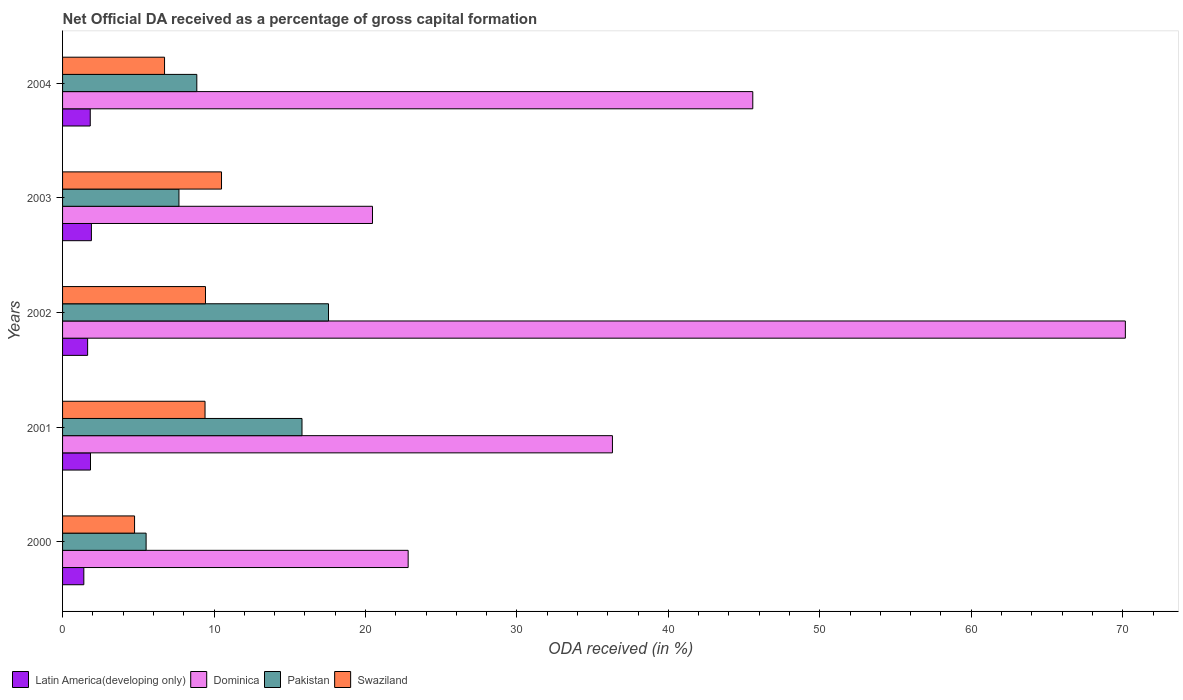How many groups of bars are there?
Make the answer very short. 5. Are the number of bars on each tick of the Y-axis equal?
Your answer should be very brief. Yes. How many bars are there on the 3rd tick from the bottom?
Keep it short and to the point. 4. What is the label of the 4th group of bars from the top?
Offer a terse response. 2001. What is the net ODA received in Dominica in 2002?
Your answer should be very brief. 70.17. Across all years, what is the maximum net ODA received in Pakistan?
Ensure brevity in your answer.  17.56. Across all years, what is the minimum net ODA received in Pakistan?
Provide a succinct answer. 5.52. In which year was the net ODA received in Latin America(developing only) minimum?
Your answer should be compact. 2000. What is the total net ODA received in Latin America(developing only) in the graph?
Offer a very short reply. 8.64. What is the difference between the net ODA received in Swaziland in 2002 and that in 2004?
Provide a short and direct response. 2.7. What is the difference between the net ODA received in Swaziland in 2001 and the net ODA received in Pakistan in 2003?
Ensure brevity in your answer.  1.72. What is the average net ODA received in Dominica per year?
Provide a short and direct response. 39.07. In the year 2002, what is the difference between the net ODA received in Latin America(developing only) and net ODA received in Swaziland?
Ensure brevity in your answer.  -7.78. In how many years, is the net ODA received in Latin America(developing only) greater than 18 %?
Give a very brief answer. 0. What is the ratio of the net ODA received in Swaziland in 2001 to that in 2002?
Provide a short and direct response. 1. Is the net ODA received in Pakistan in 2001 less than that in 2003?
Your answer should be very brief. No. What is the difference between the highest and the second highest net ODA received in Latin America(developing only)?
Make the answer very short. 0.06. What is the difference between the highest and the lowest net ODA received in Swaziland?
Keep it short and to the point. 5.74. Is it the case that in every year, the sum of the net ODA received in Pakistan and net ODA received in Swaziland is greater than the sum of net ODA received in Dominica and net ODA received in Latin America(developing only)?
Give a very brief answer. No. What does the 4th bar from the top in 2004 represents?
Your answer should be compact. Latin America(developing only). What does the 1st bar from the bottom in 2004 represents?
Make the answer very short. Latin America(developing only). Is it the case that in every year, the sum of the net ODA received in Pakistan and net ODA received in Swaziland is greater than the net ODA received in Latin America(developing only)?
Make the answer very short. Yes. How many bars are there?
Keep it short and to the point. 20. Are all the bars in the graph horizontal?
Your answer should be compact. Yes. How many years are there in the graph?
Offer a terse response. 5. What is the difference between two consecutive major ticks on the X-axis?
Keep it short and to the point. 10. Are the values on the major ticks of X-axis written in scientific E-notation?
Your response must be concise. No. Does the graph contain any zero values?
Your answer should be very brief. No. Does the graph contain grids?
Ensure brevity in your answer.  No. Where does the legend appear in the graph?
Your answer should be very brief. Bottom left. How many legend labels are there?
Keep it short and to the point. 4. What is the title of the graph?
Offer a terse response. Net Official DA received as a percentage of gross capital formation. Does "Other small states" appear as one of the legend labels in the graph?
Keep it short and to the point. No. What is the label or title of the X-axis?
Your answer should be compact. ODA received (in %). What is the ODA received (in %) in Latin America(developing only) in 2000?
Your answer should be compact. 1.4. What is the ODA received (in %) in Dominica in 2000?
Your response must be concise. 22.82. What is the ODA received (in %) in Pakistan in 2000?
Ensure brevity in your answer.  5.52. What is the ODA received (in %) of Swaziland in 2000?
Your answer should be compact. 4.75. What is the ODA received (in %) in Latin America(developing only) in 2001?
Your answer should be compact. 1.84. What is the ODA received (in %) of Dominica in 2001?
Offer a very short reply. 36.31. What is the ODA received (in %) of Pakistan in 2001?
Ensure brevity in your answer.  15.81. What is the ODA received (in %) in Swaziland in 2001?
Provide a short and direct response. 9.41. What is the ODA received (in %) of Latin America(developing only) in 2002?
Give a very brief answer. 1.65. What is the ODA received (in %) of Dominica in 2002?
Make the answer very short. 70.17. What is the ODA received (in %) of Pakistan in 2002?
Make the answer very short. 17.56. What is the ODA received (in %) in Swaziland in 2002?
Ensure brevity in your answer.  9.44. What is the ODA received (in %) of Latin America(developing only) in 2003?
Your response must be concise. 1.9. What is the ODA received (in %) of Dominica in 2003?
Provide a succinct answer. 20.46. What is the ODA received (in %) in Pakistan in 2003?
Give a very brief answer. 7.68. What is the ODA received (in %) of Swaziland in 2003?
Your answer should be compact. 10.5. What is the ODA received (in %) of Latin America(developing only) in 2004?
Your answer should be very brief. 1.83. What is the ODA received (in %) of Dominica in 2004?
Offer a terse response. 45.57. What is the ODA received (in %) of Pakistan in 2004?
Give a very brief answer. 8.86. What is the ODA received (in %) of Swaziland in 2004?
Your answer should be compact. 6.73. Across all years, what is the maximum ODA received (in %) of Latin America(developing only)?
Your response must be concise. 1.9. Across all years, what is the maximum ODA received (in %) of Dominica?
Give a very brief answer. 70.17. Across all years, what is the maximum ODA received (in %) of Pakistan?
Your answer should be compact. 17.56. Across all years, what is the maximum ODA received (in %) of Swaziland?
Ensure brevity in your answer.  10.5. Across all years, what is the minimum ODA received (in %) in Latin America(developing only)?
Make the answer very short. 1.4. Across all years, what is the minimum ODA received (in %) of Dominica?
Provide a short and direct response. 20.46. Across all years, what is the minimum ODA received (in %) in Pakistan?
Your response must be concise. 5.52. Across all years, what is the minimum ODA received (in %) in Swaziland?
Your response must be concise. 4.75. What is the total ODA received (in %) in Latin America(developing only) in the graph?
Give a very brief answer. 8.64. What is the total ODA received (in %) of Dominica in the graph?
Your response must be concise. 195.33. What is the total ODA received (in %) in Pakistan in the graph?
Your response must be concise. 55.43. What is the total ODA received (in %) of Swaziland in the graph?
Keep it short and to the point. 40.83. What is the difference between the ODA received (in %) in Latin America(developing only) in 2000 and that in 2001?
Offer a very short reply. -0.44. What is the difference between the ODA received (in %) in Dominica in 2000 and that in 2001?
Ensure brevity in your answer.  -13.49. What is the difference between the ODA received (in %) of Pakistan in 2000 and that in 2001?
Make the answer very short. -10.29. What is the difference between the ODA received (in %) of Swaziland in 2000 and that in 2001?
Keep it short and to the point. -4.65. What is the difference between the ODA received (in %) of Latin America(developing only) in 2000 and that in 2002?
Keep it short and to the point. -0.25. What is the difference between the ODA received (in %) in Dominica in 2000 and that in 2002?
Provide a short and direct response. -47.35. What is the difference between the ODA received (in %) of Pakistan in 2000 and that in 2002?
Make the answer very short. -12.04. What is the difference between the ODA received (in %) in Swaziland in 2000 and that in 2002?
Keep it short and to the point. -4.68. What is the difference between the ODA received (in %) in Latin America(developing only) in 2000 and that in 2003?
Ensure brevity in your answer.  -0.5. What is the difference between the ODA received (in %) of Dominica in 2000 and that in 2003?
Give a very brief answer. 2.35. What is the difference between the ODA received (in %) in Pakistan in 2000 and that in 2003?
Give a very brief answer. -2.17. What is the difference between the ODA received (in %) in Swaziland in 2000 and that in 2003?
Your response must be concise. -5.74. What is the difference between the ODA received (in %) in Latin America(developing only) in 2000 and that in 2004?
Provide a succinct answer. -0.42. What is the difference between the ODA received (in %) in Dominica in 2000 and that in 2004?
Offer a very short reply. -22.75. What is the difference between the ODA received (in %) in Pakistan in 2000 and that in 2004?
Your answer should be very brief. -3.35. What is the difference between the ODA received (in %) of Swaziland in 2000 and that in 2004?
Offer a terse response. -1.98. What is the difference between the ODA received (in %) of Latin America(developing only) in 2001 and that in 2002?
Keep it short and to the point. 0.19. What is the difference between the ODA received (in %) in Dominica in 2001 and that in 2002?
Make the answer very short. -33.87. What is the difference between the ODA received (in %) of Pakistan in 2001 and that in 2002?
Keep it short and to the point. -1.75. What is the difference between the ODA received (in %) of Swaziland in 2001 and that in 2002?
Ensure brevity in your answer.  -0.03. What is the difference between the ODA received (in %) of Latin America(developing only) in 2001 and that in 2003?
Your answer should be compact. -0.06. What is the difference between the ODA received (in %) of Dominica in 2001 and that in 2003?
Make the answer very short. 15.84. What is the difference between the ODA received (in %) in Pakistan in 2001 and that in 2003?
Your answer should be compact. 8.12. What is the difference between the ODA received (in %) of Swaziland in 2001 and that in 2003?
Your answer should be compact. -1.09. What is the difference between the ODA received (in %) of Latin America(developing only) in 2001 and that in 2004?
Offer a terse response. 0.02. What is the difference between the ODA received (in %) of Dominica in 2001 and that in 2004?
Keep it short and to the point. -9.27. What is the difference between the ODA received (in %) of Pakistan in 2001 and that in 2004?
Offer a terse response. 6.94. What is the difference between the ODA received (in %) in Swaziland in 2001 and that in 2004?
Ensure brevity in your answer.  2.67. What is the difference between the ODA received (in %) in Latin America(developing only) in 2002 and that in 2003?
Make the answer very short. -0.25. What is the difference between the ODA received (in %) in Dominica in 2002 and that in 2003?
Provide a succinct answer. 49.71. What is the difference between the ODA received (in %) of Pakistan in 2002 and that in 2003?
Offer a terse response. 9.87. What is the difference between the ODA received (in %) in Swaziland in 2002 and that in 2003?
Offer a terse response. -1.06. What is the difference between the ODA received (in %) of Latin America(developing only) in 2002 and that in 2004?
Give a very brief answer. -0.17. What is the difference between the ODA received (in %) in Dominica in 2002 and that in 2004?
Your answer should be very brief. 24.6. What is the difference between the ODA received (in %) in Pakistan in 2002 and that in 2004?
Provide a short and direct response. 8.7. What is the difference between the ODA received (in %) of Swaziland in 2002 and that in 2004?
Your answer should be very brief. 2.7. What is the difference between the ODA received (in %) of Latin America(developing only) in 2003 and that in 2004?
Offer a terse response. 0.08. What is the difference between the ODA received (in %) in Dominica in 2003 and that in 2004?
Provide a succinct answer. -25.11. What is the difference between the ODA received (in %) of Pakistan in 2003 and that in 2004?
Give a very brief answer. -1.18. What is the difference between the ODA received (in %) of Swaziland in 2003 and that in 2004?
Offer a very short reply. 3.76. What is the difference between the ODA received (in %) of Latin America(developing only) in 2000 and the ODA received (in %) of Dominica in 2001?
Provide a succinct answer. -34.9. What is the difference between the ODA received (in %) of Latin America(developing only) in 2000 and the ODA received (in %) of Pakistan in 2001?
Provide a short and direct response. -14.4. What is the difference between the ODA received (in %) in Latin America(developing only) in 2000 and the ODA received (in %) in Swaziland in 2001?
Offer a very short reply. -8. What is the difference between the ODA received (in %) in Dominica in 2000 and the ODA received (in %) in Pakistan in 2001?
Offer a terse response. 7.01. What is the difference between the ODA received (in %) in Dominica in 2000 and the ODA received (in %) in Swaziland in 2001?
Your answer should be very brief. 13.41. What is the difference between the ODA received (in %) in Pakistan in 2000 and the ODA received (in %) in Swaziland in 2001?
Your response must be concise. -3.89. What is the difference between the ODA received (in %) of Latin America(developing only) in 2000 and the ODA received (in %) of Dominica in 2002?
Your response must be concise. -68.77. What is the difference between the ODA received (in %) of Latin America(developing only) in 2000 and the ODA received (in %) of Pakistan in 2002?
Provide a short and direct response. -16.16. What is the difference between the ODA received (in %) in Latin America(developing only) in 2000 and the ODA received (in %) in Swaziland in 2002?
Your answer should be compact. -8.03. What is the difference between the ODA received (in %) of Dominica in 2000 and the ODA received (in %) of Pakistan in 2002?
Keep it short and to the point. 5.26. What is the difference between the ODA received (in %) of Dominica in 2000 and the ODA received (in %) of Swaziland in 2002?
Offer a very short reply. 13.38. What is the difference between the ODA received (in %) of Pakistan in 2000 and the ODA received (in %) of Swaziland in 2002?
Make the answer very short. -3.92. What is the difference between the ODA received (in %) in Latin America(developing only) in 2000 and the ODA received (in %) in Dominica in 2003?
Your answer should be very brief. -19.06. What is the difference between the ODA received (in %) in Latin America(developing only) in 2000 and the ODA received (in %) in Pakistan in 2003?
Keep it short and to the point. -6.28. What is the difference between the ODA received (in %) in Latin America(developing only) in 2000 and the ODA received (in %) in Swaziland in 2003?
Ensure brevity in your answer.  -9.09. What is the difference between the ODA received (in %) in Dominica in 2000 and the ODA received (in %) in Pakistan in 2003?
Your answer should be compact. 15.13. What is the difference between the ODA received (in %) in Dominica in 2000 and the ODA received (in %) in Swaziland in 2003?
Provide a short and direct response. 12.32. What is the difference between the ODA received (in %) of Pakistan in 2000 and the ODA received (in %) of Swaziland in 2003?
Provide a succinct answer. -4.98. What is the difference between the ODA received (in %) of Latin America(developing only) in 2000 and the ODA received (in %) of Dominica in 2004?
Ensure brevity in your answer.  -44.17. What is the difference between the ODA received (in %) in Latin America(developing only) in 2000 and the ODA received (in %) in Pakistan in 2004?
Provide a short and direct response. -7.46. What is the difference between the ODA received (in %) in Latin America(developing only) in 2000 and the ODA received (in %) in Swaziland in 2004?
Provide a short and direct response. -5.33. What is the difference between the ODA received (in %) in Dominica in 2000 and the ODA received (in %) in Pakistan in 2004?
Provide a succinct answer. 13.95. What is the difference between the ODA received (in %) of Dominica in 2000 and the ODA received (in %) of Swaziland in 2004?
Offer a terse response. 16.08. What is the difference between the ODA received (in %) of Pakistan in 2000 and the ODA received (in %) of Swaziland in 2004?
Your answer should be very brief. -1.22. What is the difference between the ODA received (in %) of Latin America(developing only) in 2001 and the ODA received (in %) of Dominica in 2002?
Make the answer very short. -68.33. What is the difference between the ODA received (in %) of Latin America(developing only) in 2001 and the ODA received (in %) of Pakistan in 2002?
Keep it short and to the point. -15.71. What is the difference between the ODA received (in %) in Latin America(developing only) in 2001 and the ODA received (in %) in Swaziland in 2002?
Your answer should be very brief. -7.59. What is the difference between the ODA received (in %) of Dominica in 2001 and the ODA received (in %) of Pakistan in 2002?
Provide a short and direct response. 18.75. What is the difference between the ODA received (in %) in Dominica in 2001 and the ODA received (in %) in Swaziland in 2002?
Your answer should be compact. 26.87. What is the difference between the ODA received (in %) in Pakistan in 2001 and the ODA received (in %) in Swaziland in 2002?
Ensure brevity in your answer.  6.37. What is the difference between the ODA received (in %) in Latin America(developing only) in 2001 and the ODA received (in %) in Dominica in 2003?
Your response must be concise. -18.62. What is the difference between the ODA received (in %) in Latin America(developing only) in 2001 and the ODA received (in %) in Pakistan in 2003?
Ensure brevity in your answer.  -5.84. What is the difference between the ODA received (in %) in Latin America(developing only) in 2001 and the ODA received (in %) in Swaziland in 2003?
Your answer should be very brief. -8.65. What is the difference between the ODA received (in %) in Dominica in 2001 and the ODA received (in %) in Pakistan in 2003?
Keep it short and to the point. 28.62. What is the difference between the ODA received (in %) in Dominica in 2001 and the ODA received (in %) in Swaziland in 2003?
Provide a short and direct response. 25.81. What is the difference between the ODA received (in %) of Pakistan in 2001 and the ODA received (in %) of Swaziland in 2003?
Provide a succinct answer. 5.31. What is the difference between the ODA received (in %) of Latin America(developing only) in 2001 and the ODA received (in %) of Dominica in 2004?
Give a very brief answer. -43.73. What is the difference between the ODA received (in %) of Latin America(developing only) in 2001 and the ODA received (in %) of Pakistan in 2004?
Keep it short and to the point. -7.02. What is the difference between the ODA received (in %) in Latin America(developing only) in 2001 and the ODA received (in %) in Swaziland in 2004?
Offer a terse response. -4.89. What is the difference between the ODA received (in %) in Dominica in 2001 and the ODA received (in %) in Pakistan in 2004?
Provide a short and direct response. 27.44. What is the difference between the ODA received (in %) of Dominica in 2001 and the ODA received (in %) of Swaziland in 2004?
Make the answer very short. 29.57. What is the difference between the ODA received (in %) in Pakistan in 2001 and the ODA received (in %) in Swaziland in 2004?
Ensure brevity in your answer.  9.08. What is the difference between the ODA received (in %) in Latin America(developing only) in 2002 and the ODA received (in %) in Dominica in 2003?
Your answer should be very brief. -18.81. What is the difference between the ODA received (in %) of Latin America(developing only) in 2002 and the ODA received (in %) of Pakistan in 2003?
Ensure brevity in your answer.  -6.03. What is the difference between the ODA received (in %) in Latin America(developing only) in 2002 and the ODA received (in %) in Swaziland in 2003?
Give a very brief answer. -8.84. What is the difference between the ODA received (in %) of Dominica in 2002 and the ODA received (in %) of Pakistan in 2003?
Your answer should be compact. 62.49. What is the difference between the ODA received (in %) of Dominica in 2002 and the ODA received (in %) of Swaziland in 2003?
Make the answer very short. 59.68. What is the difference between the ODA received (in %) of Pakistan in 2002 and the ODA received (in %) of Swaziland in 2003?
Make the answer very short. 7.06. What is the difference between the ODA received (in %) of Latin America(developing only) in 2002 and the ODA received (in %) of Dominica in 2004?
Your answer should be compact. -43.92. What is the difference between the ODA received (in %) in Latin America(developing only) in 2002 and the ODA received (in %) in Pakistan in 2004?
Make the answer very short. -7.21. What is the difference between the ODA received (in %) in Latin America(developing only) in 2002 and the ODA received (in %) in Swaziland in 2004?
Keep it short and to the point. -5.08. What is the difference between the ODA received (in %) of Dominica in 2002 and the ODA received (in %) of Pakistan in 2004?
Provide a succinct answer. 61.31. What is the difference between the ODA received (in %) in Dominica in 2002 and the ODA received (in %) in Swaziland in 2004?
Give a very brief answer. 63.44. What is the difference between the ODA received (in %) of Pakistan in 2002 and the ODA received (in %) of Swaziland in 2004?
Your answer should be very brief. 10.83. What is the difference between the ODA received (in %) in Latin America(developing only) in 2003 and the ODA received (in %) in Dominica in 2004?
Offer a very short reply. -43.67. What is the difference between the ODA received (in %) of Latin America(developing only) in 2003 and the ODA received (in %) of Pakistan in 2004?
Your answer should be very brief. -6.96. What is the difference between the ODA received (in %) in Latin America(developing only) in 2003 and the ODA received (in %) in Swaziland in 2004?
Your response must be concise. -4.83. What is the difference between the ODA received (in %) of Dominica in 2003 and the ODA received (in %) of Pakistan in 2004?
Give a very brief answer. 11.6. What is the difference between the ODA received (in %) of Dominica in 2003 and the ODA received (in %) of Swaziland in 2004?
Give a very brief answer. 13.73. What is the difference between the ODA received (in %) in Pakistan in 2003 and the ODA received (in %) in Swaziland in 2004?
Provide a short and direct response. 0.95. What is the average ODA received (in %) in Latin America(developing only) per year?
Keep it short and to the point. 1.73. What is the average ODA received (in %) of Dominica per year?
Give a very brief answer. 39.07. What is the average ODA received (in %) in Pakistan per year?
Offer a terse response. 11.09. What is the average ODA received (in %) of Swaziland per year?
Keep it short and to the point. 8.17. In the year 2000, what is the difference between the ODA received (in %) in Latin America(developing only) and ODA received (in %) in Dominica?
Your answer should be very brief. -21.41. In the year 2000, what is the difference between the ODA received (in %) in Latin America(developing only) and ODA received (in %) in Pakistan?
Make the answer very short. -4.11. In the year 2000, what is the difference between the ODA received (in %) of Latin America(developing only) and ODA received (in %) of Swaziland?
Offer a terse response. -3.35. In the year 2000, what is the difference between the ODA received (in %) of Dominica and ODA received (in %) of Pakistan?
Give a very brief answer. 17.3. In the year 2000, what is the difference between the ODA received (in %) of Dominica and ODA received (in %) of Swaziland?
Your response must be concise. 18.06. In the year 2000, what is the difference between the ODA received (in %) in Pakistan and ODA received (in %) in Swaziland?
Give a very brief answer. 0.76. In the year 2001, what is the difference between the ODA received (in %) of Latin America(developing only) and ODA received (in %) of Dominica?
Your answer should be compact. -34.46. In the year 2001, what is the difference between the ODA received (in %) in Latin America(developing only) and ODA received (in %) in Pakistan?
Provide a short and direct response. -13.96. In the year 2001, what is the difference between the ODA received (in %) in Latin America(developing only) and ODA received (in %) in Swaziland?
Ensure brevity in your answer.  -7.56. In the year 2001, what is the difference between the ODA received (in %) in Dominica and ODA received (in %) in Pakistan?
Your answer should be compact. 20.5. In the year 2001, what is the difference between the ODA received (in %) in Dominica and ODA received (in %) in Swaziland?
Keep it short and to the point. 26.9. In the year 2001, what is the difference between the ODA received (in %) in Pakistan and ODA received (in %) in Swaziland?
Keep it short and to the point. 6.4. In the year 2002, what is the difference between the ODA received (in %) of Latin America(developing only) and ODA received (in %) of Dominica?
Make the answer very short. -68.52. In the year 2002, what is the difference between the ODA received (in %) of Latin America(developing only) and ODA received (in %) of Pakistan?
Provide a short and direct response. -15.9. In the year 2002, what is the difference between the ODA received (in %) of Latin America(developing only) and ODA received (in %) of Swaziland?
Keep it short and to the point. -7.78. In the year 2002, what is the difference between the ODA received (in %) in Dominica and ODA received (in %) in Pakistan?
Make the answer very short. 52.61. In the year 2002, what is the difference between the ODA received (in %) in Dominica and ODA received (in %) in Swaziland?
Your answer should be compact. 60.74. In the year 2002, what is the difference between the ODA received (in %) in Pakistan and ODA received (in %) in Swaziland?
Your answer should be compact. 8.12. In the year 2003, what is the difference between the ODA received (in %) in Latin America(developing only) and ODA received (in %) in Dominica?
Offer a very short reply. -18.56. In the year 2003, what is the difference between the ODA received (in %) in Latin America(developing only) and ODA received (in %) in Pakistan?
Provide a short and direct response. -5.78. In the year 2003, what is the difference between the ODA received (in %) of Latin America(developing only) and ODA received (in %) of Swaziland?
Offer a terse response. -8.59. In the year 2003, what is the difference between the ODA received (in %) in Dominica and ODA received (in %) in Pakistan?
Provide a succinct answer. 12.78. In the year 2003, what is the difference between the ODA received (in %) in Dominica and ODA received (in %) in Swaziland?
Provide a short and direct response. 9.97. In the year 2003, what is the difference between the ODA received (in %) in Pakistan and ODA received (in %) in Swaziland?
Give a very brief answer. -2.81. In the year 2004, what is the difference between the ODA received (in %) of Latin America(developing only) and ODA received (in %) of Dominica?
Make the answer very short. -43.75. In the year 2004, what is the difference between the ODA received (in %) in Latin America(developing only) and ODA received (in %) in Pakistan?
Offer a very short reply. -7.04. In the year 2004, what is the difference between the ODA received (in %) of Latin America(developing only) and ODA received (in %) of Swaziland?
Keep it short and to the point. -4.91. In the year 2004, what is the difference between the ODA received (in %) in Dominica and ODA received (in %) in Pakistan?
Give a very brief answer. 36.71. In the year 2004, what is the difference between the ODA received (in %) in Dominica and ODA received (in %) in Swaziland?
Ensure brevity in your answer.  38.84. In the year 2004, what is the difference between the ODA received (in %) of Pakistan and ODA received (in %) of Swaziland?
Give a very brief answer. 2.13. What is the ratio of the ODA received (in %) of Latin America(developing only) in 2000 to that in 2001?
Offer a terse response. 0.76. What is the ratio of the ODA received (in %) of Dominica in 2000 to that in 2001?
Ensure brevity in your answer.  0.63. What is the ratio of the ODA received (in %) in Pakistan in 2000 to that in 2001?
Your answer should be very brief. 0.35. What is the ratio of the ODA received (in %) in Swaziland in 2000 to that in 2001?
Offer a very short reply. 0.51. What is the ratio of the ODA received (in %) of Latin America(developing only) in 2000 to that in 2002?
Offer a very short reply. 0.85. What is the ratio of the ODA received (in %) in Dominica in 2000 to that in 2002?
Make the answer very short. 0.33. What is the ratio of the ODA received (in %) of Pakistan in 2000 to that in 2002?
Offer a terse response. 0.31. What is the ratio of the ODA received (in %) in Swaziland in 2000 to that in 2002?
Ensure brevity in your answer.  0.5. What is the ratio of the ODA received (in %) in Latin America(developing only) in 2000 to that in 2003?
Your answer should be very brief. 0.74. What is the ratio of the ODA received (in %) in Dominica in 2000 to that in 2003?
Provide a short and direct response. 1.12. What is the ratio of the ODA received (in %) of Pakistan in 2000 to that in 2003?
Your answer should be compact. 0.72. What is the ratio of the ODA received (in %) of Swaziland in 2000 to that in 2003?
Offer a terse response. 0.45. What is the ratio of the ODA received (in %) of Latin America(developing only) in 2000 to that in 2004?
Your response must be concise. 0.77. What is the ratio of the ODA received (in %) in Dominica in 2000 to that in 2004?
Your answer should be very brief. 0.5. What is the ratio of the ODA received (in %) of Pakistan in 2000 to that in 2004?
Ensure brevity in your answer.  0.62. What is the ratio of the ODA received (in %) of Swaziland in 2000 to that in 2004?
Offer a very short reply. 0.71. What is the ratio of the ODA received (in %) in Latin America(developing only) in 2001 to that in 2002?
Keep it short and to the point. 1.11. What is the ratio of the ODA received (in %) in Dominica in 2001 to that in 2002?
Ensure brevity in your answer.  0.52. What is the ratio of the ODA received (in %) of Pakistan in 2001 to that in 2002?
Your answer should be very brief. 0.9. What is the ratio of the ODA received (in %) in Latin America(developing only) in 2001 to that in 2003?
Your answer should be compact. 0.97. What is the ratio of the ODA received (in %) in Dominica in 2001 to that in 2003?
Provide a succinct answer. 1.77. What is the ratio of the ODA received (in %) of Pakistan in 2001 to that in 2003?
Keep it short and to the point. 2.06. What is the ratio of the ODA received (in %) of Swaziland in 2001 to that in 2003?
Offer a very short reply. 0.9. What is the ratio of the ODA received (in %) in Latin America(developing only) in 2001 to that in 2004?
Keep it short and to the point. 1.01. What is the ratio of the ODA received (in %) in Dominica in 2001 to that in 2004?
Give a very brief answer. 0.8. What is the ratio of the ODA received (in %) in Pakistan in 2001 to that in 2004?
Offer a very short reply. 1.78. What is the ratio of the ODA received (in %) of Swaziland in 2001 to that in 2004?
Provide a short and direct response. 1.4. What is the ratio of the ODA received (in %) in Latin America(developing only) in 2002 to that in 2003?
Your answer should be compact. 0.87. What is the ratio of the ODA received (in %) of Dominica in 2002 to that in 2003?
Your response must be concise. 3.43. What is the ratio of the ODA received (in %) in Pakistan in 2002 to that in 2003?
Provide a short and direct response. 2.29. What is the ratio of the ODA received (in %) in Swaziland in 2002 to that in 2003?
Offer a terse response. 0.9. What is the ratio of the ODA received (in %) of Latin America(developing only) in 2002 to that in 2004?
Provide a short and direct response. 0.91. What is the ratio of the ODA received (in %) of Dominica in 2002 to that in 2004?
Keep it short and to the point. 1.54. What is the ratio of the ODA received (in %) of Pakistan in 2002 to that in 2004?
Offer a very short reply. 1.98. What is the ratio of the ODA received (in %) in Swaziland in 2002 to that in 2004?
Provide a short and direct response. 1.4. What is the ratio of the ODA received (in %) of Latin America(developing only) in 2003 to that in 2004?
Provide a succinct answer. 1.04. What is the ratio of the ODA received (in %) of Dominica in 2003 to that in 2004?
Ensure brevity in your answer.  0.45. What is the ratio of the ODA received (in %) in Pakistan in 2003 to that in 2004?
Give a very brief answer. 0.87. What is the ratio of the ODA received (in %) in Swaziland in 2003 to that in 2004?
Provide a succinct answer. 1.56. What is the difference between the highest and the second highest ODA received (in %) in Latin America(developing only)?
Provide a short and direct response. 0.06. What is the difference between the highest and the second highest ODA received (in %) of Dominica?
Make the answer very short. 24.6. What is the difference between the highest and the second highest ODA received (in %) of Pakistan?
Give a very brief answer. 1.75. What is the difference between the highest and the second highest ODA received (in %) in Swaziland?
Your answer should be very brief. 1.06. What is the difference between the highest and the lowest ODA received (in %) of Latin America(developing only)?
Your answer should be compact. 0.5. What is the difference between the highest and the lowest ODA received (in %) of Dominica?
Ensure brevity in your answer.  49.71. What is the difference between the highest and the lowest ODA received (in %) in Pakistan?
Give a very brief answer. 12.04. What is the difference between the highest and the lowest ODA received (in %) of Swaziland?
Offer a terse response. 5.74. 